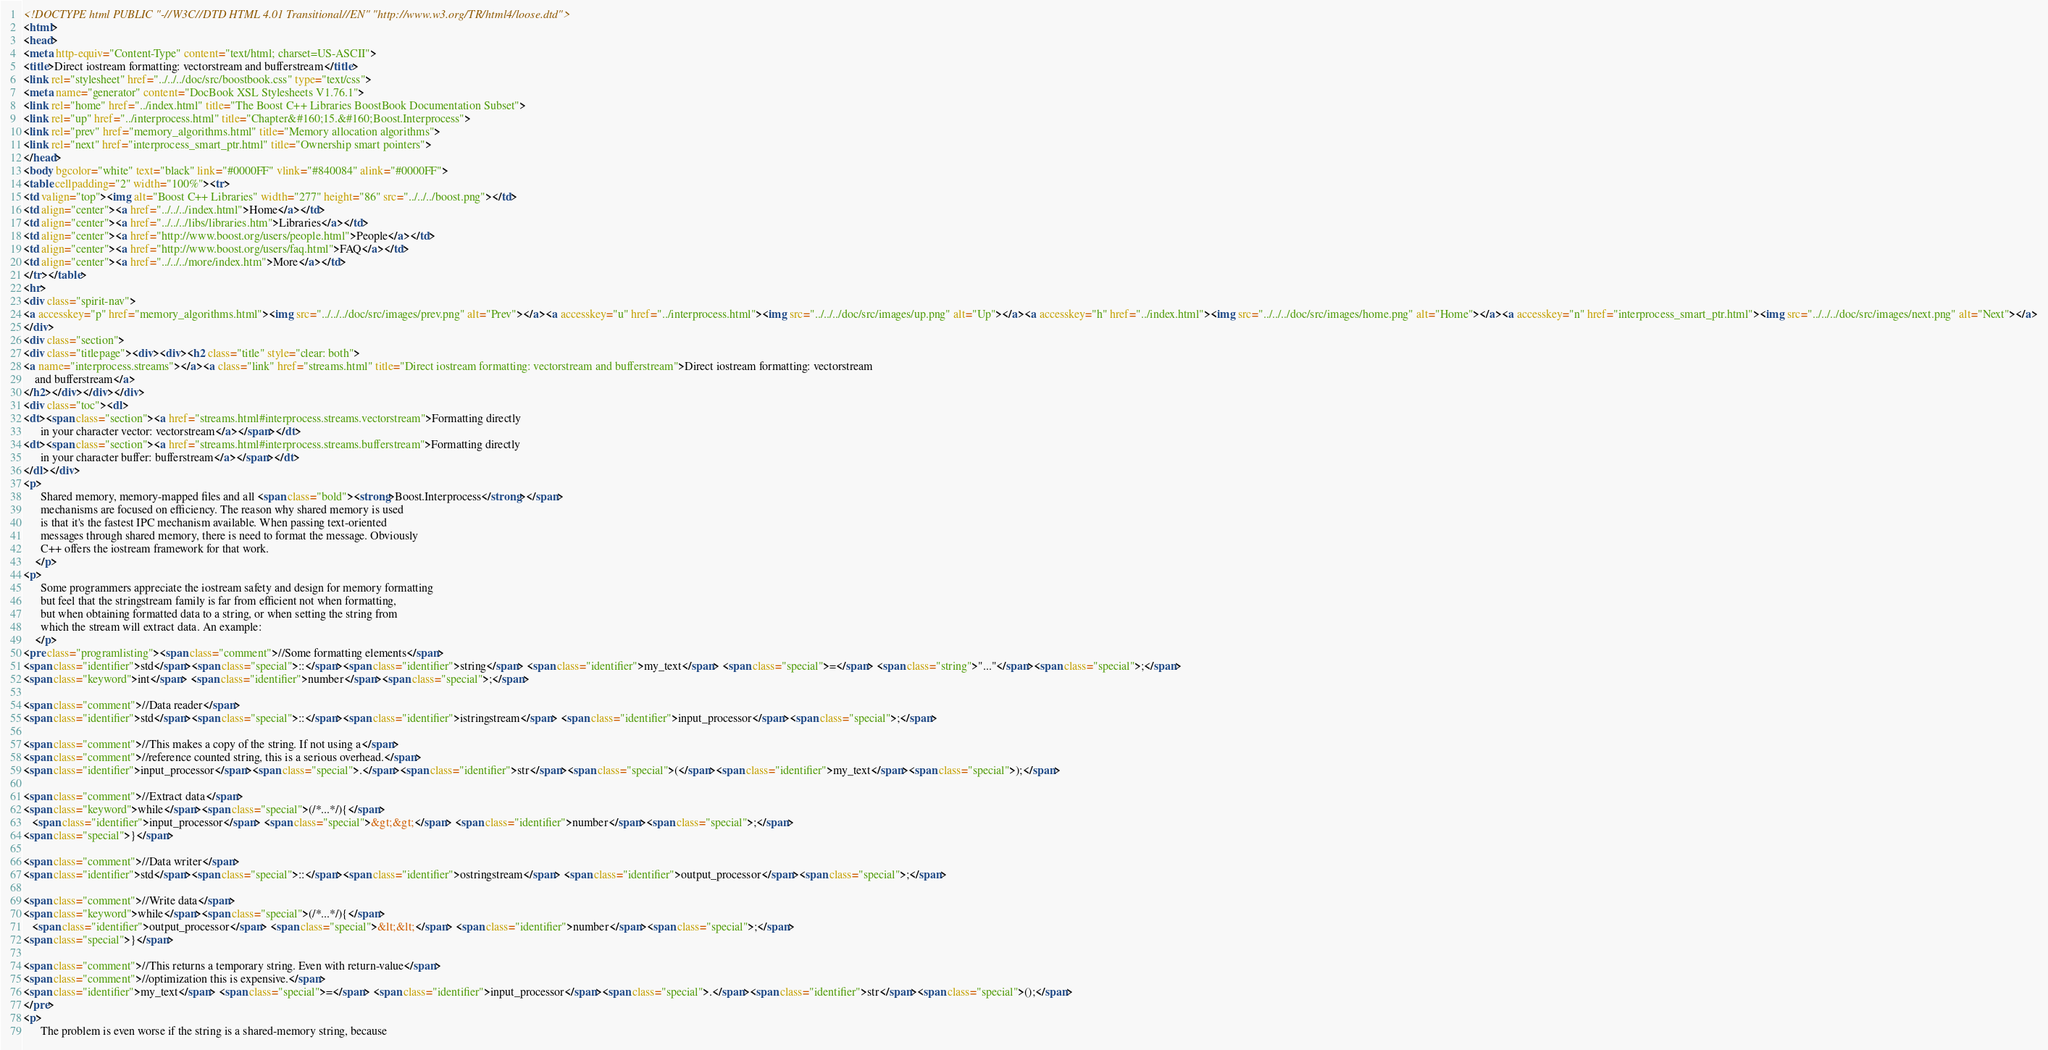Convert code to text. <code><loc_0><loc_0><loc_500><loc_500><_HTML_><!DOCTYPE html PUBLIC "-//W3C//DTD HTML 4.01 Transitional//EN" "http://www.w3.org/TR/html4/loose.dtd">
<html>
<head>
<meta http-equiv="Content-Type" content="text/html; charset=US-ASCII">
<title>Direct iostream formatting: vectorstream and bufferstream</title>
<link rel="stylesheet" href="../../../doc/src/boostbook.css" type="text/css">
<meta name="generator" content="DocBook XSL Stylesheets V1.76.1">
<link rel="home" href="../index.html" title="The Boost C++ Libraries BoostBook Documentation Subset">
<link rel="up" href="../interprocess.html" title="Chapter&#160;15.&#160;Boost.Interprocess">
<link rel="prev" href="memory_algorithms.html" title="Memory allocation algorithms">
<link rel="next" href="interprocess_smart_ptr.html" title="Ownership smart pointers">
</head>
<body bgcolor="white" text="black" link="#0000FF" vlink="#840084" alink="#0000FF">
<table cellpadding="2" width="100%"><tr>
<td valign="top"><img alt="Boost C++ Libraries" width="277" height="86" src="../../../boost.png"></td>
<td align="center"><a href="../../../index.html">Home</a></td>
<td align="center"><a href="../../../libs/libraries.htm">Libraries</a></td>
<td align="center"><a href="http://www.boost.org/users/people.html">People</a></td>
<td align="center"><a href="http://www.boost.org/users/faq.html">FAQ</a></td>
<td align="center"><a href="../../../more/index.htm">More</a></td>
</tr></table>
<hr>
<div class="spirit-nav">
<a accesskey="p" href="memory_algorithms.html"><img src="../../../doc/src/images/prev.png" alt="Prev"></a><a accesskey="u" href="../interprocess.html"><img src="../../../doc/src/images/up.png" alt="Up"></a><a accesskey="h" href="../index.html"><img src="../../../doc/src/images/home.png" alt="Home"></a><a accesskey="n" href="interprocess_smart_ptr.html"><img src="../../../doc/src/images/next.png" alt="Next"></a>
</div>
<div class="section">
<div class="titlepage"><div><div><h2 class="title" style="clear: both">
<a name="interprocess.streams"></a><a class="link" href="streams.html" title="Direct iostream formatting: vectorstream and bufferstream">Direct iostream formatting: vectorstream
    and bufferstream</a>
</h2></div></div></div>
<div class="toc"><dl>
<dt><span class="section"><a href="streams.html#interprocess.streams.vectorstream">Formatting directly
      in your character vector: vectorstream</a></span></dt>
<dt><span class="section"><a href="streams.html#interprocess.streams.bufferstream">Formatting directly
      in your character buffer: bufferstream</a></span></dt>
</dl></div>
<p>
      Shared memory, memory-mapped files and all <span class="bold"><strong>Boost.Interprocess</strong></span>
      mechanisms are focused on efficiency. The reason why shared memory is used
      is that it's the fastest IPC mechanism available. When passing text-oriented
      messages through shared memory, there is need to format the message. Obviously
      C++ offers the iostream framework for that work.
    </p>
<p>
      Some programmers appreciate the iostream safety and design for memory formatting
      but feel that the stringstream family is far from efficient not when formatting,
      but when obtaining formatted data to a string, or when setting the string from
      which the stream will extract data. An example:
    </p>
<pre class="programlisting"><span class="comment">//Some formatting elements</span>
<span class="identifier">std</span><span class="special">::</span><span class="identifier">string</span> <span class="identifier">my_text</span> <span class="special">=</span> <span class="string">"..."</span><span class="special">;</span>
<span class="keyword">int</span> <span class="identifier">number</span><span class="special">;</span>

<span class="comment">//Data reader</span>
<span class="identifier">std</span><span class="special">::</span><span class="identifier">istringstream</span> <span class="identifier">input_processor</span><span class="special">;</span>

<span class="comment">//This makes a copy of the string. If not using a</span>
<span class="comment">//reference counted string, this is a serious overhead.</span>
<span class="identifier">input_processor</span><span class="special">.</span><span class="identifier">str</span><span class="special">(</span><span class="identifier">my_text</span><span class="special">);</span>

<span class="comment">//Extract data</span>
<span class="keyword">while</span><span class="special">(/*...*/){</span>
   <span class="identifier">input_processor</span> <span class="special">&gt;&gt;</span> <span class="identifier">number</span><span class="special">;</span>
<span class="special">}</span>

<span class="comment">//Data writer</span>
<span class="identifier">std</span><span class="special">::</span><span class="identifier">ostringstream</span> <span class="identifier">output_processor</span><span class="special">;</span>

<span class="comment">//Write data</span>
<span class="keyword">while</span><span class="special">(/*...*/){</span>
   <span class="identifier">output_processor</span> <span class="special">&lt;&lt;</span> <span class="identifier">number</span><span class="special">;</span>
<span class="special">}</span>

<span class="comment">//This returns a temporary string. Even with return-value</span>
<span class="comment">//optimization this is expensive.</span>
<span class="identifier">my_text</span> <span class="special">=</span> <span class="identifier">input_processor</span><span class="special">.</span><span class="identifier">str</span><span class="special">();</span>
</pre>
<p>
      The problem is even worse if the string is a shared-memory string, because</code> 